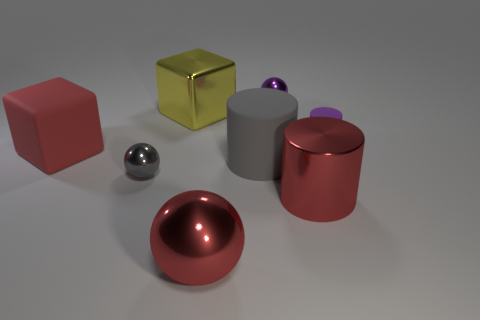What number of tiny metallic things are on the right side of the large red sphere and on the left side of the large red metallic ball?
Ensure brevity in your answer.  0. Are there any other large metal objects of the same shape as the gray shiny thing?
Give a very brief answer. Yes. There is a gray object that is the same size as the purple matte cylinder; what is its shape?
Make the answer very short. Sphere. Are there an equal number of large red matte cubes left of the purple metal sphere and small gray things that are on the right side of the gray cylinder?
Provide a succinct answer. No. There is a cylinder that is to the left of the small metal object behind the small purple rubber object; how big is it?
Keep it short and to the point. Large. Are there any purple spheres of the same size as the yellow block?
Offer a very short reply. No. What is the color of the cylinder that is the same material as the tiny gray sphere?
Your answer should be compact. Red. Is the number of purple things less than the number of red cylinders?
Your answer should be compact. No. What is the material of the large thing that is behind the tiny gray object and on the right side of the metal block?
Keep it short and to the point. Rubber. Is there a small purple cylinder that is on the left side of the tiny sphere on the right side of the large matte cylinder?
Provide a succinct answer. No. 